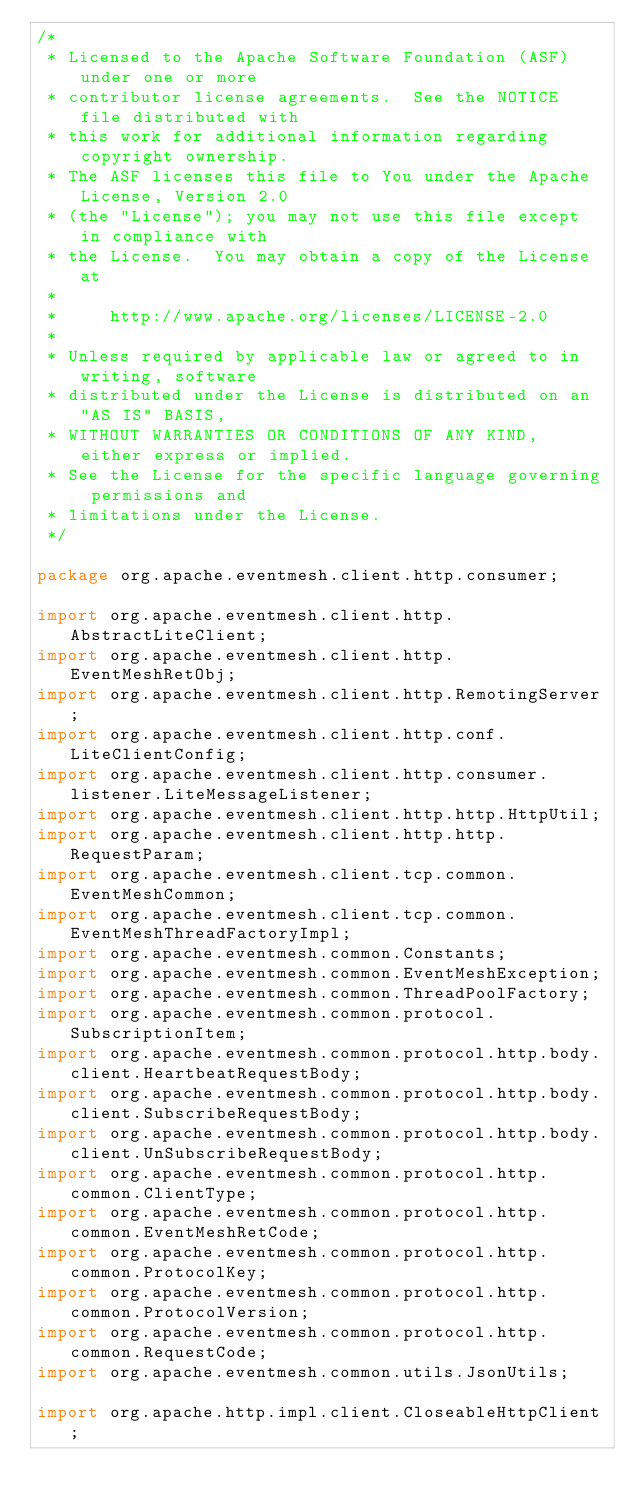Convert code to text. <code><loc_0><loc_0><loc_500><loc_500><_Java_>/*
 * Licensed to the Apache Software Foundation (ASF) under one or more
 * contributor license agreements.  See the NOTICE file distributed with
 * this work for additional information regarding copyright ownership.
 * The ASF licenses this file to You under the Apache License, Version 2.0
 * (the "License"); you may not use this file except in compliance with
 * the License.  You may obtain a copy of the License at
 *
 *     http://www.apache.org/licenses/LICENSE-2.0
 *
 * Unless required by applicable law or agreed to in writing, software
 * distributed under the License is distributed on an "AS IS" BASIS,
 * WITHOUT WARRANTIES OR CONDITIONS OF ANY KIND, either express or implied.
 * See the License for the specific language governing permissions and
 * limitations under the License.
 */

package org.apache.eventmesh.client.http.consumer;

import org.apache.eventmesh.client.http.AbstractLiteClient;
import org.apache.eventmesh.client.http.EventMeshRetObj;
import org.apache.eventmesh.client.http.RemotingServer;
import org.apache.eventmesh.client.http.conf.LiteClientConfig;
import org.apache.eventmesh.client.http.consumer.listener.LiteMessageListener;
import org.apache.eventmesh.client.http.http.HttpUtil;
import org.apache.eventmesh.client.http.http.RequestParam;
import org.apache.eventmesh.client.tcp.common.EventMeshCommon;
import org.apache.eventmesh.client.tcp.common.EventMeshThreadFactoryImpl;
import org.apache.eventmesh.common.Constants;
import org.apache.eventmesh.common.EventMeshException;
import org.apache.eventmesh.common.ThreadPoolFactory;
import org.apache.eventmesh.common.protocol.SubscriptionItem;
import org.apache.eventmesh.common.protocol.http.body.client.HeartbeatRequestBody;
import org.apache.eventmesh.common.protocol.http.body.client.SubscribeRequestBody;
import org.apache.eventmesh.common.protocol.http.body.client.UnSubscribeRequestBody;
import org.apache.eventmesh.common.protocol.http.common.ClientType;
import org.apache.eventmesh.common.protocol.http.common.EventMeshRetCode;
import org.apache.eventmesh.common.protocol.http.common.ProtocolKey;
import org.apache.eventmesh.common.protocol.http.common.ProtocolVersion;
import org.apache.eventmesh.common.protocol.http.common.RequestCode;
import org.apache.eventmesh.common.utils.JsonUtils;

import org.apache.http.impl.client.CloseableHttpClient;
</code> 